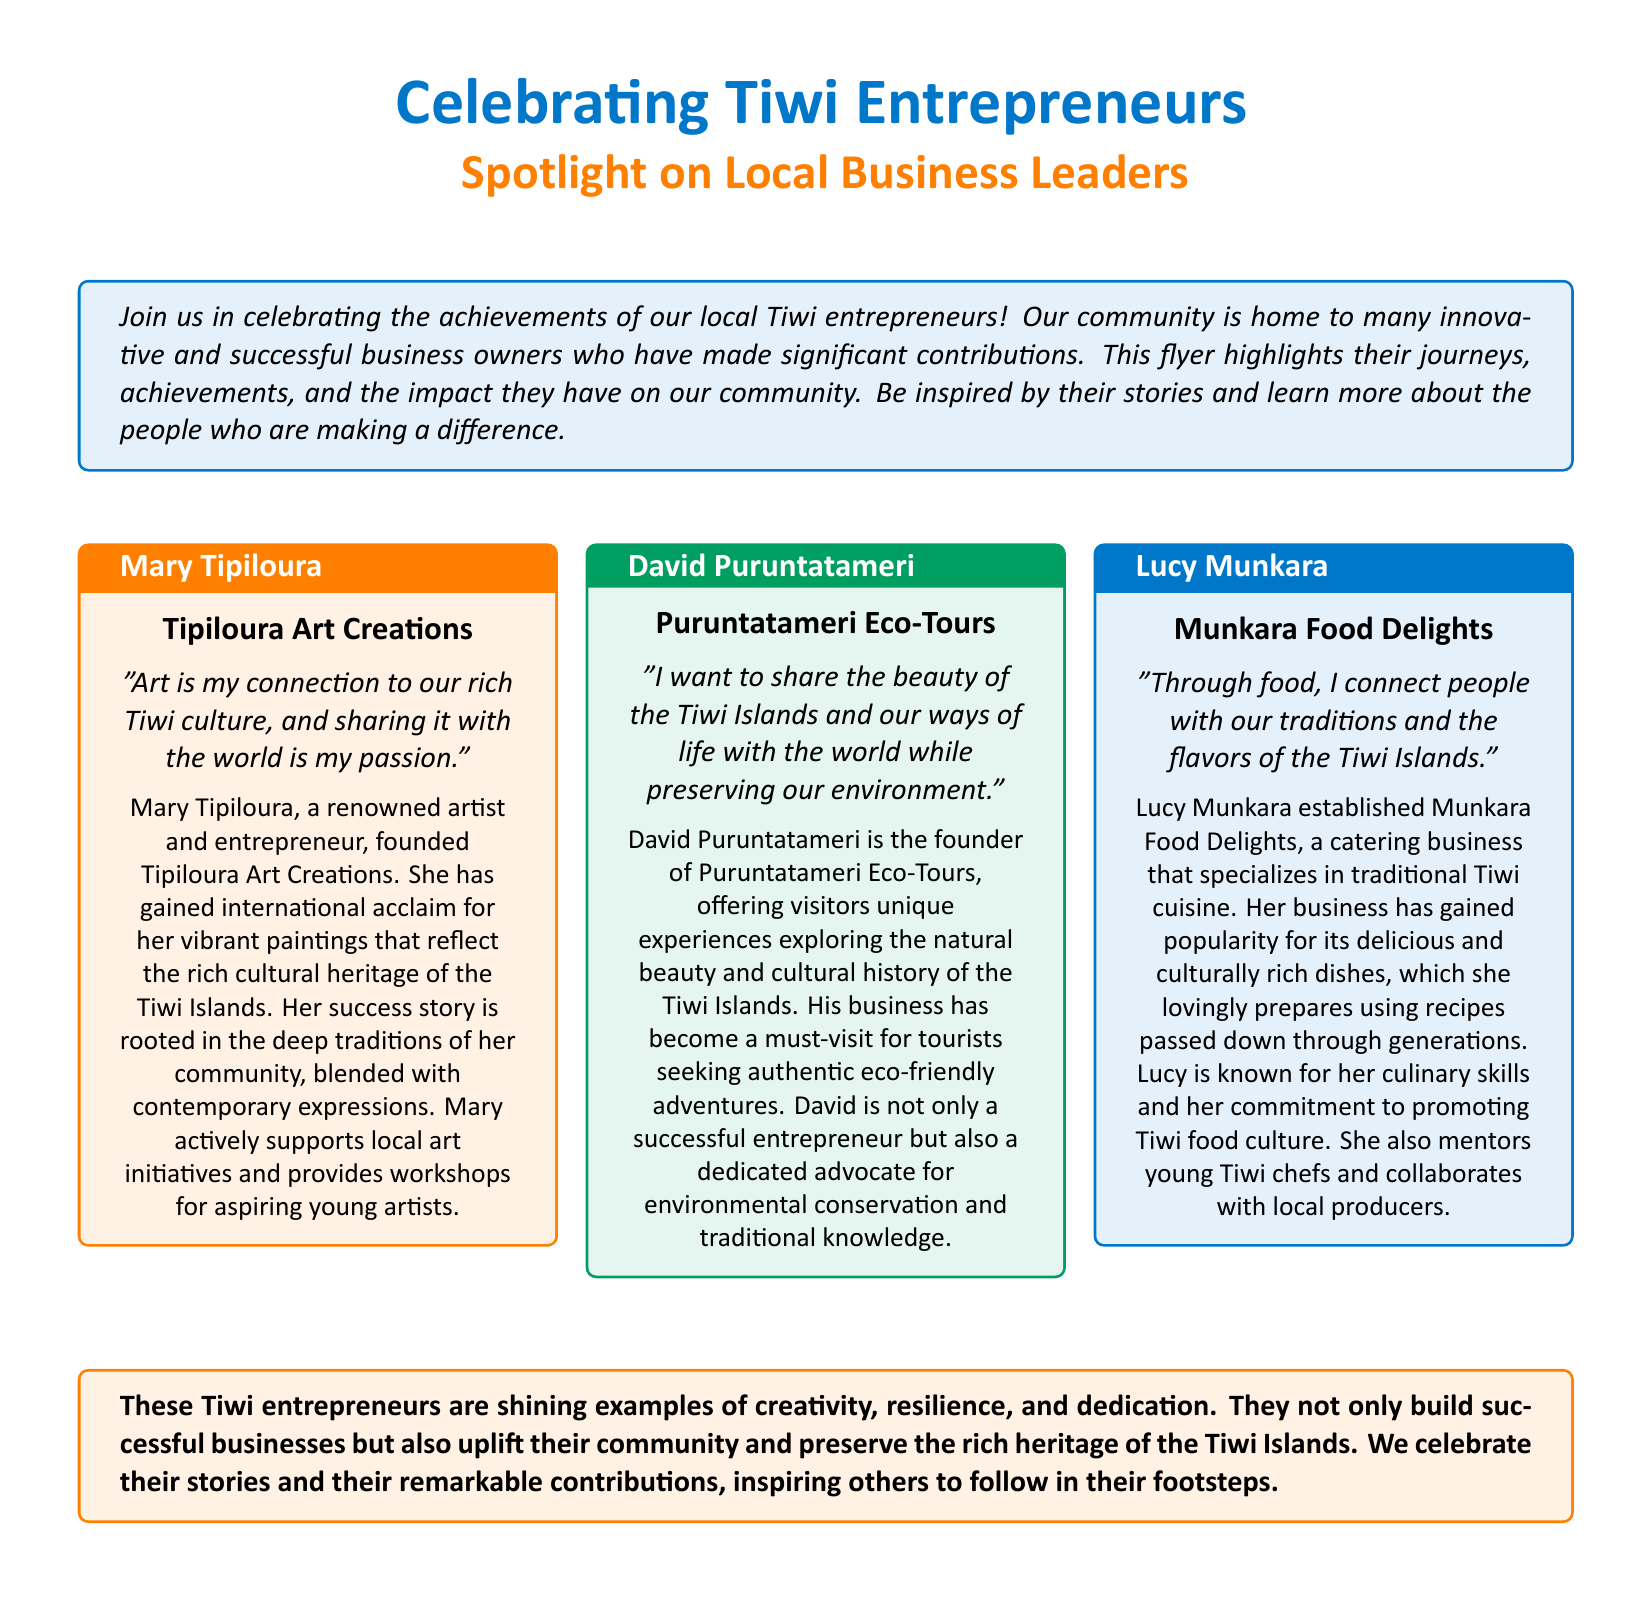What is the title of the flyer? The title prominently displayed at the top of the flyer is "Celebrating Tiwi Entrepreneurs."
Answer: Celebrating Tiwi Entrepreneurs Who is the founder of Tipiloura Art Creations? The flyer states that Mary Tipiloura is the founder of Tipiloura Art Creations.
Answer: Mary Tipiloura What type of business does David Puruntatameri run? According to the flyer, David Puruntatameri runs Puruntatameri Eco-Tours.
Answer: Eco-Tours What is Lucy Munkara's business focused on? The flyer indicates that Lucy Munkara's business, Munkara Food Delights, specializes in traditional Tiwi cuisine.
Answer: Traditional Tiwi cuisine Name one contribution of Mary Tipiloura to the community. The flyer mentions that Mary actively supports local art initiatives and provides workshops for aspiring young artists.
Answer: Workshops for aspiring young artists How many entrepreneurs are spotlighted in the flyer? The flyer profiles three successful Tiwi entrepreneurs.
Answer: Three What is a common theme among the entrepreneurs highlighted in the flyer? The shared theme among the entrepreneurs is the commitment to preserving and promoting Tiwi culture.
Answer: Preserving and promoting Tiwi culture Which color is used for the box containing David Puruntatameri's profile? The box containing David Puruntatameri's profile uses the color tiwigreen.
Answer: tiwigreen What type of cuisine does Munkara Food Delights serve? The flyer specifies that Munkara Food Delights serves delicious and culturally rich dishes.
Answer: Culturally rich dishes 